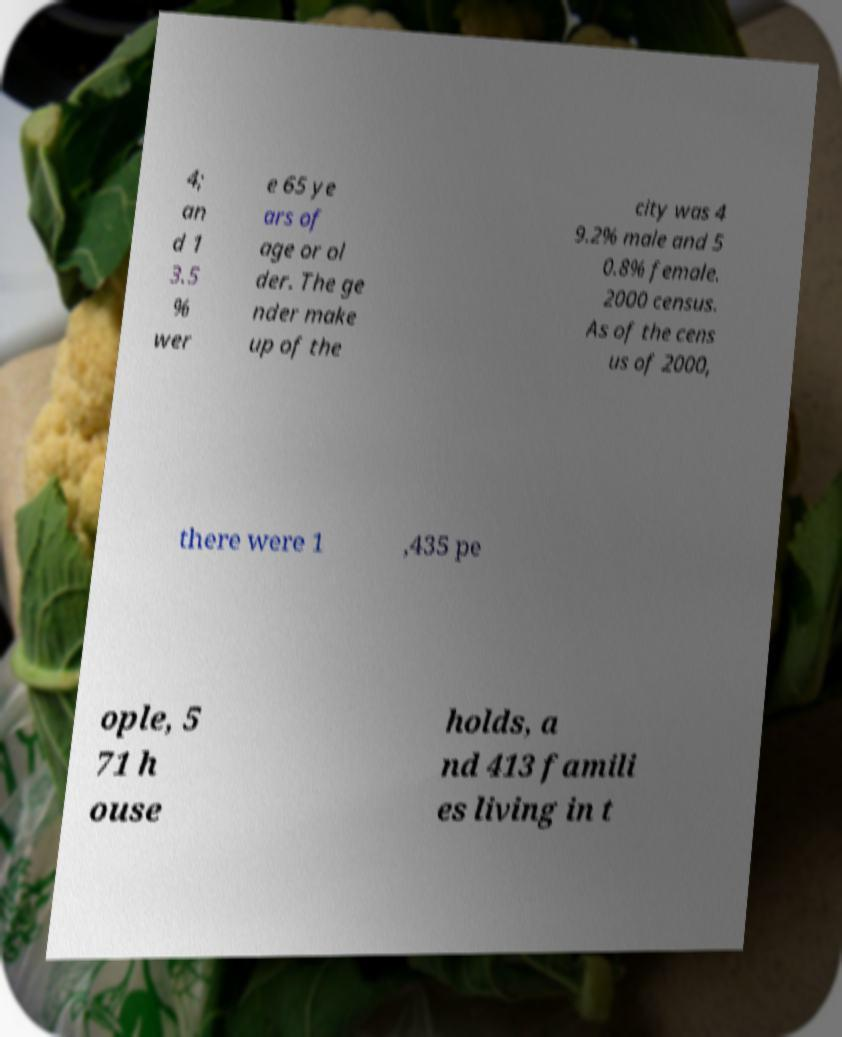There's text embedded in this image that I need extracted. Can you transcribe it verbatim? 4; an d 1 3.5 % wer e 65 ye ars of age or ol der. The ge nder make up of the city was 4 9.2% male and 5 0.8% female. 2000 census. As of the cens us of 2000, there were 1 ,435 pe ople, 5 71 h ouse holds, a nd 413 famili es living in t 